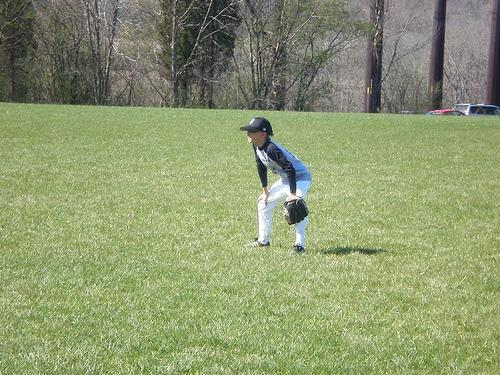What aspect of the game is being shown here? outfield 